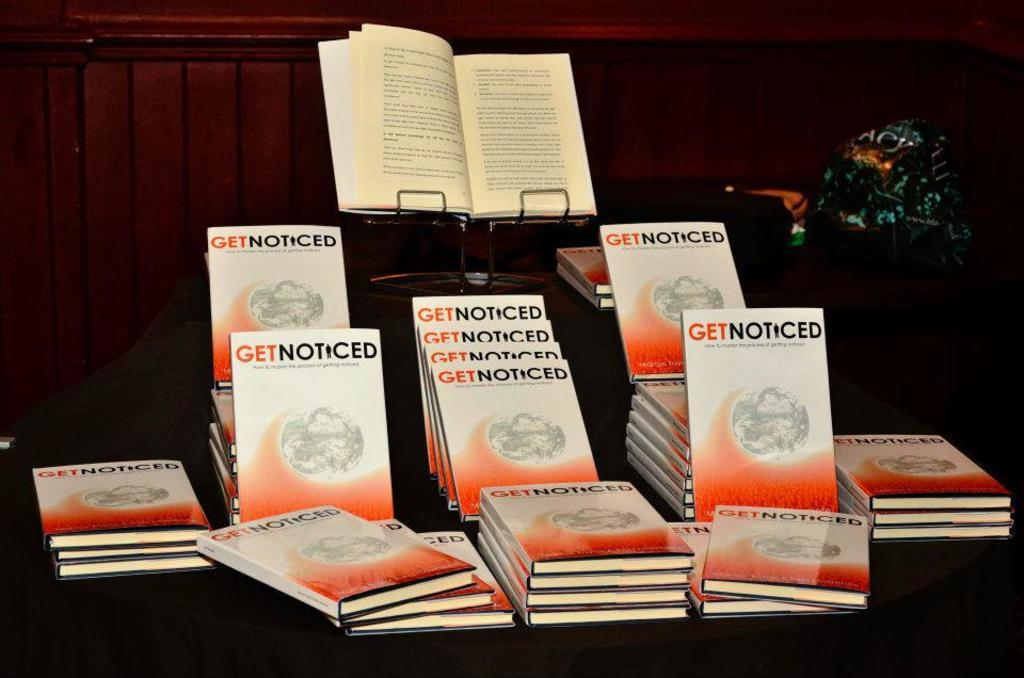Provide a one-sentence caption for the provided image. A book called Get Noticed is on display on a dark table. 